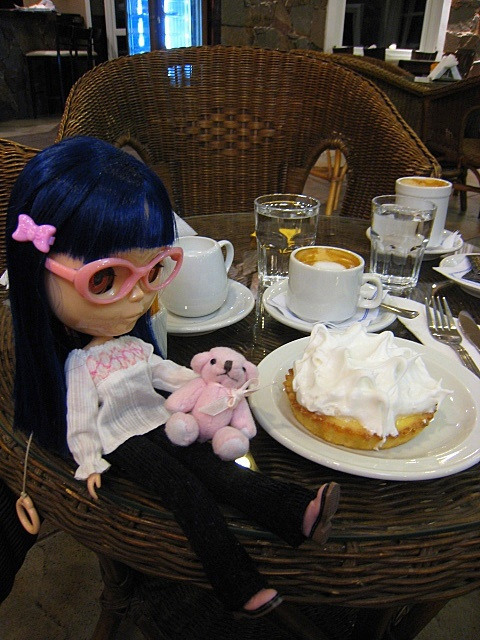Describe the objects in this image and their specific colors. I can see dining table in black, darkgray, and lightgray tones, chair in black, maroon, and gray tones, cake in black, lightgray, olive, and tan tones, teddy bear in black, pink, darkgray, and gray tones, and cup in black, darkgray, lightgray, and olive tones in this image. 